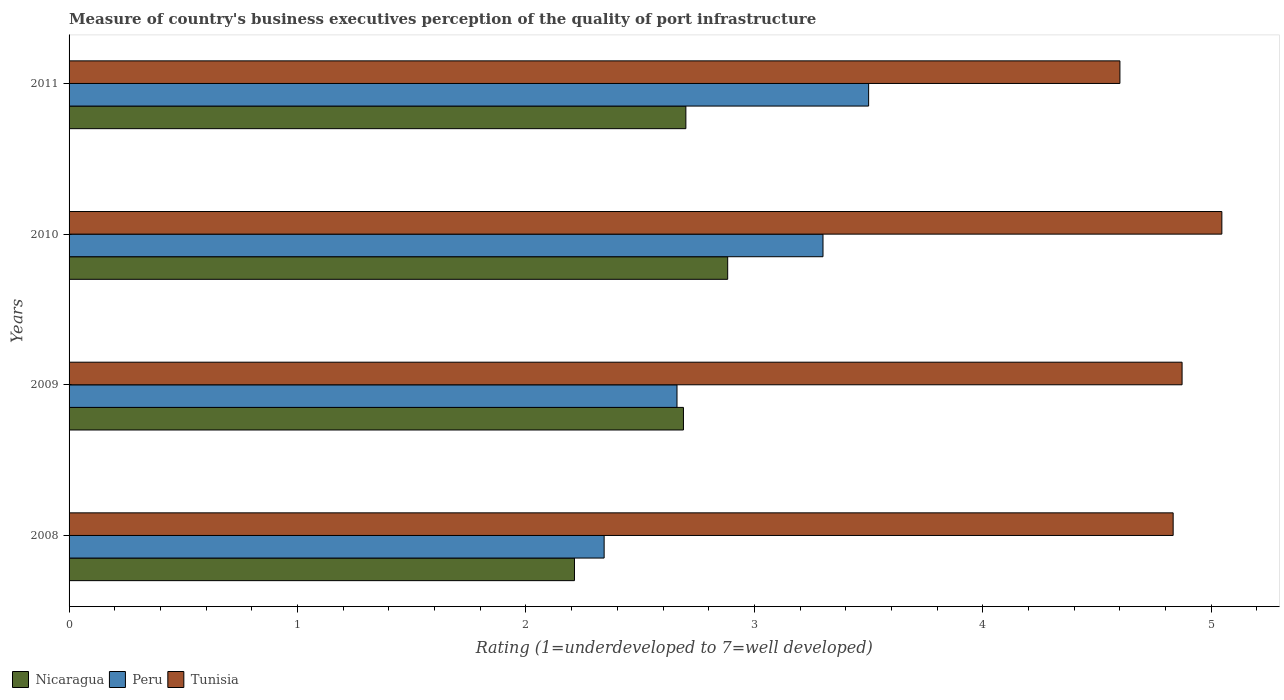How many different coloured bars are there?
Your response must be concise. 3. How many groups of bars are there?
Your response must be concise. 4. How many bars are there on the 3rd tick from the bottom?
Ensure brevity in your answer.  3. In how many cases, is the number of bars for a given year not equal to the number of legend labels?
Provide a succinct answer. 0. What is the ratings of the quality of port infrastructure in Peru in 2009?
Offer a terse response. 2.66. Across all years, what is the maximum ratings of the quality of port infrastructure in Tunisia?
Your answer should be very brief. 5.05. Across all years, what is the minimum ratings of the quality of port infrastructure in Peru?
Provide a succinct answer. 2.34. What is the total ratings of the quality of port infrastructure in Peru in the graph?
Ensure brevity in your answer.  11.8. What is the difference between the ratings of the quality of port infrastructure in Peru in 2008 and that in 2009?
Your response must be concise. -0.32. What is the difference between the ratings of the quality of port infrastructure in Nicaragua in 2010 and the ratings of the quality of port infrastructure in Tunisia in 2009?
Keep it short and to the point. -1.99. What is the average ratings of the quality of port infrastructure in Peru per year?
Offer a very short reply. 2.95. In the year 2010, what is the difference between the ratings of the quality of port infrastructure in Nicaragua and ratings of the quality of port infrastructure in Tunisia?
Provide a short and direct response. -2.16. In how many years, is the ratings of the quality of port infrastructure in Peru greater than 0.8 ?
Your answer should be compact. 4. What is the ratio of the ratings of the quality of port infrastructure in Peru in 2010 to that in 2011?
Ensure brevity in your answer.  0.94. What is the difference between the highest and the second highest ratings of the quality of port infrastructure in Nicaragua?
Make the answer very short. 0.18. What is the difference between the highest and the lowest ratings of the quality of port infrastructure in Peru?
Make the answer very short. 1.16. In how many years, is the ratings of the quality of port infrastructure in Nicaragua greater than the average ratings of the quality of port infrastructure in Nicaragua taken over all years?
Make the answer very short. 3. Is the sum of the ratings of the quality of port infrastructure in Tunisia in 2009 and 2010 greater than the maximum ratings of the quality of port infrastructure in Nicaragua across all years?
Provide a short and direct response. Yes. What does the 1st bar from the top in 2010 represents?
Your response must be concise. Tunisia. What does the 3rd bar from the bottom in 2009 represents?
Provide a short and direct response. Tunisia. How many bars are there?
Make the answer very short. 12. Are all the bars in the graph horizontal?
Give a very brief answer. Yes. What is the difference between two consecutive major ticks on the X-axis?
Keep it short and to the point. 1. Does the graph contain any zero values?
Ensure brevity in your answer.  No. Does the graph contain grids?
Make the answer very short. No. Where does the legend appear in the graph?
Make the answer very short. Bottom left. How are the legend labels stacked?
Your response must be concise. Horizontal. What is the title of the graph?
Ensure brevity in your answer.  Measure of country's business executives perception of the quality of port infrastructure. What is the label or title of the X-axis?
Provide a succinct answer. Rating (1=underdeveloped to 7=well developed). What is the label or title of the Y-axis?
Your answer should be very brief. Years. What is the Rating (1=underdeveloped to 7=well developed) in Nicaragua in 2008?
Your response must be concise. 2.21. What is the Rating (1=underdeveloped to 7=well developed) in Peru in 2008?
Make the answer very short. 2.34. What is the Rating (1=underdeveloped to 7=well developed) in Tunisia in 2008?
Give a very brief answer. 4.83. What is the Rating (1=underdeveloped to 7=well developed) in Nicaragua in 2009?
Offer a very short reply. 2.69. What is the Rating (1=underdeveloped to 7=well developed) in Peru in 2009?
Provide a short and direct response. 2.66. What is the Rating (1=underdeveloped to 7=well developed) of Tunisia in 2009?
Provide a succinct answer. 4.87. What is the Rating (1=underdeveloped to 7=well developed) in Nicaragua in 2010?
Your answer should be very brief. 2.88. What is the Rating (1=underdeveloped to 7=well developed) of Peru in 2010?
Provide a succinct answer. 3.3. What is the Rating (1=underdeveloped to 7=well developed) of Tunisia in 2010?
Your response must be concise. 5.05. What is the Rating (1=underdeveloped to 7=well developed) of Peru in 2011?
Provide a succinct answer. 3.5. Across all years, what is the maximum Rating (1=underdeveloped to 7=well developed) of Nicaragua?
Offer a very short reply. 2.88. Across all years, what is the maximum Rating (1=underdeveloped to 7=well developed) of Tunisia?
Make the answer very short. 5.05. Across all years, what is the minimum Rating (1=underdeveloped to 7=well developed) of Nicaragua?
Ensure brevity in your answer.  2.21. Across all years, what is the minimum Rating (1=underdeveloped to 7=well developed) of Peru?
Provide a succinct answer. 2.34. Across all years, what is the minimum Rating (1=underdeveloped to 7=well developed) in Tunisia?
Offer a terse response. 4.6. What is the total Rating (1=underdeveloped to 7=well developed) of Nicaragua in the graph?
Your response must be concise. 10.48. What is the total Rating (1=underdeveloped to 7=well developed) in Peru in the graph?
Offer a very short reply. 11.8. What is the total Rating (1=underdeveloped to 7=well developed) in Tunisia in the graph?
Your answer should be compact. 19.35. What is the difference between the Rating (1=underdeveloped to 7=well developed) of Nicaragua in 2008 and that in 2009?
Offer a very short reply. -0.48. What is the difference between the Rating (1=underdeveloped to 7=well developed) in Peru in 2008 and that in 2009?
Make the answer very short. -0.32. What is the difference between the Rating (1=underdeveloped to 7=well developed) in Tunisia in 2008 and that in 2009?
Offer a terse response. -0.04. What is the difference between the Rating (1=underdeveloped to 7=well developed) in Nicaragua in 2008 and that in 2010?
Keep it short and to the point. -0.67. What is the difference between the Rating (1=underdeveloped to 7=well developed) of Peru in 2008 and that in 2010?
Make the answer very short. -0.96. What is the difference between the Rating (1=underdeveloped to 7=well developed) of Tunisia in 2008 and that in 2010?
Offer a terse response. -0.21. What is the difference between the Rating (1=underdeveloped to 7=well developed) of Nicaragua in 2008 and that in 2011?
Offer a terse response. -0.49. What is the difference between the Rating (1=underdeveloped to 7=well developed) of Peru in 2008 and that in 2011?
Provide a short and direct response. -1.16. What is the difference between the Rating (1=underdeveloped to 7=well developed) in Tunisia in 2008 and that in 2011?
Make the answer very short. 0.23. What is the difference between the Rating (1=underdeveloped to 7=well developed) in Nicaragua in 2009 and that in 2010?
Your answer should be compact. -0.19. What is the difference between the Rating (1=underdeveloped to 7=well developed) in Peru in 2009 and that in 2010?
Your answer should be compact. -0.64. What is the difference between the Rating (1=underdeveloped to 7=well developed) in Tunisia in 2009 and that in 2010?
Make the answer very short. -0.17. What is the difference between the Rating (1=underdeveloped to 7=well developed) in Nicaragua in 2009 and that in 2011?
Provide a succinct answer. -0.01. What is the difference between the Rating (1=underdeveloped to 7=well developed) of Peru in 2009 and that in 2011?
Make the answer very short. -0.84. What is the difference between the Rating (1=underdeveloped to 7=well developed) in Tunisia in 2009 and that in 2011?
Your response must be concise. 0.27. What is the difference between the Rating (1=underdeveloped to 7=well developed) in Nicaragua in 2010 and that in 2011?
Your answer should be compact. 0.18. What is the difference between the Rating (1=underdeveloped to 7=well developed) in Peru in 2010 and that in 2011?
Make the answer very short. -0.2. What is the difference between the Rating (1=underdeveloped to 7=well developed) of Tunisia in 2010 and that in 2011?
Offer a terse response. 0.45. What is the difference between the Rating (1=underdeveloped to 7=well developed) in Nicaragua in 2008 and the Rating (1=underdeveloped to 7=well developed) in Peru in 2009?
Offer a terse response. -0.45. What is the difference between the Rating (1=underdeveloped to 7=well developed) of Nicaragua in 2008 and the Rating (1=underdeveloped to 7=well developed) of Tunisia in 2009?
Your answer should be compact. -2.66. What is the difference between the Rating (1=underdeveloped to 7=well developed) in Peru in 2008 and the Rating (1=underdeveloped to 7=well developed) in Tunisia in 2009?
Keep it short and to the point. -2.53. What is the difference between the Rating (1=underdeveloped to 7=well developed) in Nicaragua in 2008 and the Rating (1=underdeveloped to 7=well developed) in Peru in 2010?
Provide a short and direct response. -1.09. What is the difference between the Rating (1=underdeveloped to 7=well developed) of Nicaragua in 2008 and the Rating (1=underdeveloped to 7=well developed) of Tunisia in 2010?
Your response must be concise. -2.83. What is the difference between the Rating (1=underdeveloped to 7=well developed) in Peru in 2008 and the Rating (1=underdeveloped to 7=well developed) in Tunisia in 2010?
Give a very brief answer. -2.7. What is the difference between the Rating (1=underdeveloped to 7=well developed) of Nicaragua in 2008 and the Rating (1=underdeveloped to 7=well developed) of Peru in 2011?
Your response must be concise. -1.29. What is the difference between the Rating (1=underdeveloped to 7=well developed) of Nicaragua in 2008 and the Rating (1=underdeveloped to 7=well developed) of Tunisia in 2011?
Provide a short and direct response. -2.39. What is the difference between the Rating (1=underdeveloped to 7=well developed) of Peru in 2008 and the Rating (1=underdeveloped to 7=well developed) of Tunisia in 2011?
Ensure brevity in your answer.  -2.26. What is the difference between the Rating (1=underdeveloped to 7=well developed) of Nicaragua in 2009 and the Rating (1=underdeveloped to 7=well developed) of Peru in 2010?
Ensure brevity in your answer.  -0.61. What is the difference between the Rating (1=underdeveloped to 7=well developed) in Nicaragua in 2009 and the Rating (1=underdeveloped to 7=well developed) in Tunisia in 2010?
Your answer should be compact. -2.36. What is the difference between the Rating (1=underdeveloped to 7=well developed) of Peru in 2009 and the Rating (1=underdeveloped to 7=well developed) of Tunisia in 2010?
Ensure brevity in your answer.  -2.39. What is the difference between the Rating (1=underdeveloped to 7=well developed) in Nicaragua in 2009 and the Rating (1=underdeveloped to 7=well developed) in Peru in 2011?
Give a very brief answer. -0.81. What is the difference between the Rating (1=underdeveloped to 7=well developed) in Nicaragua in 2009 and the Rating (1=underdeveloped to 7=well developed) in Tunisia in 2011?
Ensure brevity in your answer.  -1.91. What is the difference between the Rating (1=underdeveloped to 7=well developed) of Peru in 2009 and the Rating (1=underdeveloped to 7=well developed) of Tunisia in 2011?
Provide a succinct answer. -1.94. What is the difference between the Rating (1=underdeveloped to 7=well developed) in Nicaragua in 2010 and the Rating (1=underdeveloped to 7=well developed) in Peru in 2011?
Offer a very short reply. -0.62. What is the difference between the Rating (1=underdeveloped to 7=well developed) in Nicaragua in 2010 and the Rating (1=underdeveloped to 7=well developed) in Tunisia in 2011?
Make the answer very short. -1.72. What is the difference between the Rating (1=underdeveloped to 7=well developed) in Peru in 2010 and the Rating (1=underdeveloped to 7=well developed) in Tunisia in 2011?
Your answer should be compact. -1.3. What is the average Rating (1=underdeveloped to 7=well developed) in Nicaragua per year?
Offer a very short reply. 2.62. What is the average Rating (1=underdeveloped to 7=well developed) in Peru per year?
Provide a succinct answer. 2.95. What is the average Rating (1=underdeveloped to 7=well developed) of Tunisia per year?
Provide a succinct answer. 4.84. In the year 2008, what is the difference between the Rating (1=underdeveloped to 7=well developed) of Nicaragua and Rating (1=underdeveloped to 7=well developed) of Peru?
Your answer should be compact. -0.13. In the year 2008, what is the difference between the Rating (1=underdeveloped to 7=well developed) of Nicaragua and Rating (1=underdeveloped to 7=well developed) of Tunisia?
Give a very brief answer. -2.62. In the year 2008, what is the difference between the Rating (1=underdeveloped to 7=well developed) of Peru and Rating (1=underdeveloped to 7=well developed) of Tunisia?
Keep it short and to the point. -2.49. In the year 2009, what is the difference between the Rating (1=underdeveloped to 7=well developed) of Nicaragua and Rating (1=underdeveloped to 7=well developed) of Peru?
Make the answer very short. 0.03. In the year 2009, what is the difference between the Rating (1=underdeveloped to 7=well developed) of Nicaragua and Rating (1=underdeveloped to 7=well developed) of Tunisia?
Provide a short and direct response. -2.18. In the year 2009, what is the difference between the Rating (1=underdeveloped to 7=well developed) in Peru and Rating (1=underdeveloped to 7=well developed) in Tunisia?
Make the answer very short. -2.21. In the year 2010, what is the difference between the Rating (1=underdeveloped to 7=well developed) in Nicaragua and Rating (1=underdeveloped to 7=well developed) in Peru?
Give a very brief answer. -0.42. In the year 2010, what is the difference between the Rating (1=underdeveloped to 7=well developed) in Nicaragua and Rating (1=underdeveloped to 7=well developed) in Tunisia?
Give a very brief answer. -2.16. In the year 2010, what is the difference between the Rating (1=underdeveloped to 7=well developed) in Peru and Rating (1=underdeveloped to 7=well developed) in Tunisia?
Ensure brevity in your answer.  -1.75. In the year 2011, what is the difference between the Rating (1=underdeveloped to 7=well developed) in Nicaragua and Rating (1=underdeveloped to 7=well developed) in Peru?
Give a very brief answer. -0.8. In the year 2011, what is the difference between the Rating (1=underdeveloped to 7=well developed) in Nicaragua and Rating (1=underdeveloped to 7=well developed) in Tunisia?
Your answer should be compact. -1.9. What is the ratio of the Rating (1=underdeveloped to 7=well developed) in Nicaragua in 2008 to that in 2009?
Provide a short and direct response. 0.82. What is the ratio of the Rating (1=underdeveloped to 7=well developed) of Peru in 2008 to that in 2009?
Make the answer very short. 0.88. What is the ratio of the Rating (1=underdeveloped to 7=well developed) in Tunisia in 2008 to that in 2009?
Provide a succinct answer. 0.99. What is the ratio of the Rating (1=underdeveloped to 7=well developed) in Nicaragua in 2008 to that in 2010?
Provide a succinct answer. 0.77. What is the ratio of the Rating (1=underdeveloped to 7=well developed) of Peru in 2008 to that in 2010?
Provide a short and direct response. 0.71. What is the ratio of the Rating (1=underdeveloped to 7=well developed) of Tunisia in 2008 to that in 2010?
Provide a succinct answer. 0.96. What is the ratio of the Rating (1=underdeveloped to 7=well developed) of Nicaragua in 2008 to that in 2011?
Offer a very short reply. 0.82. What is the ratio of the Rating (1=underdeveloped to 7=well developed) of Peru in 2008 to that in 2011?
Make the answer very short. 0.67. What is the ratio of the Rating (1=underdeveloped to 7=well developed) in Tunisia in 2008 to that in 2011?
Provide a succinct answer. 1.05. What is the ratio of the Rating (1=underdeveloped to 7=well developed) of Nicaragua in 2009 to that in 2010?
Give a very brief answer. 0.93. What is the ratio of the Rating (1=underdeveloped to 7=well developed) in Peru in 2009 to that in 2010?
Offer a very short reply. 0.81. What is the ratio of the Rating (1=underdeveloped to 7=well developed) of Tunisia in 2009 to that in 2010?
Your response must be concise. 0.97. What is the ratio of the Rating (1=underdeveloped to 7=well developed) in Nicaragua in 2009 to that in 2011?
Your response must be concise. 1. What is the ratio of the Rating (1=underdeveloped to 7=well developed) in Peru in 2009 to that in 2011?
Provide a succinct answer. 0.76. What is the ratio of the Rating (1=underdeveloped to 7=well developed) in Tunisia in 2009 to that in 2011?
Your answer should be compact. 1.06. What is the ratio of the Rating (1=underdeveloped to 7=well developed) in Nicaragua in 2010 to that in 2011?
Ensure brevity in your answer.  1.07. What is the ratio of the Rating (1=underdeveloped to 7=well developed) in Peru in 2010 to that in 2011?
Give a very brief answer. 0.94. What is the ratio of the Rating (1=underdeveloped to 7=well developed) in Tunisia in 2010 to that in 2011?
Ensure brevity in your answer.  1.1. What is the difference between the highest and the second highest Rating (1=underdeveloped to 7=well developed) of Nicaragua?
Ensure brevity in your answer.  0.18. What is the difference between the highest and the second highest Rating (1=underdeveloped to 7=well developed) in Peru?
Ensure brevity in your answer.  0.2. What is the difference between the highest and the second highest Rating (1=underdeveloped to 7=well developed) of Tunisia?
Provide a succinct answer. 0.17. What is the difference between the highest and the lowest Rating (1=underdeveloped to 7=well developed) in Nicaragua?
Provide a short and direct response. 0.67. What is the difference between the highest and the lowest Rating (1=underdeveloped to 7=well developed) in Peru?
Make the answer very short. 1.16. What is the difference between the highest and the lowest Rating (1=underdeveloped to 7=well developed) of Tunisia?
Keep it short and to the point. 0.45. 